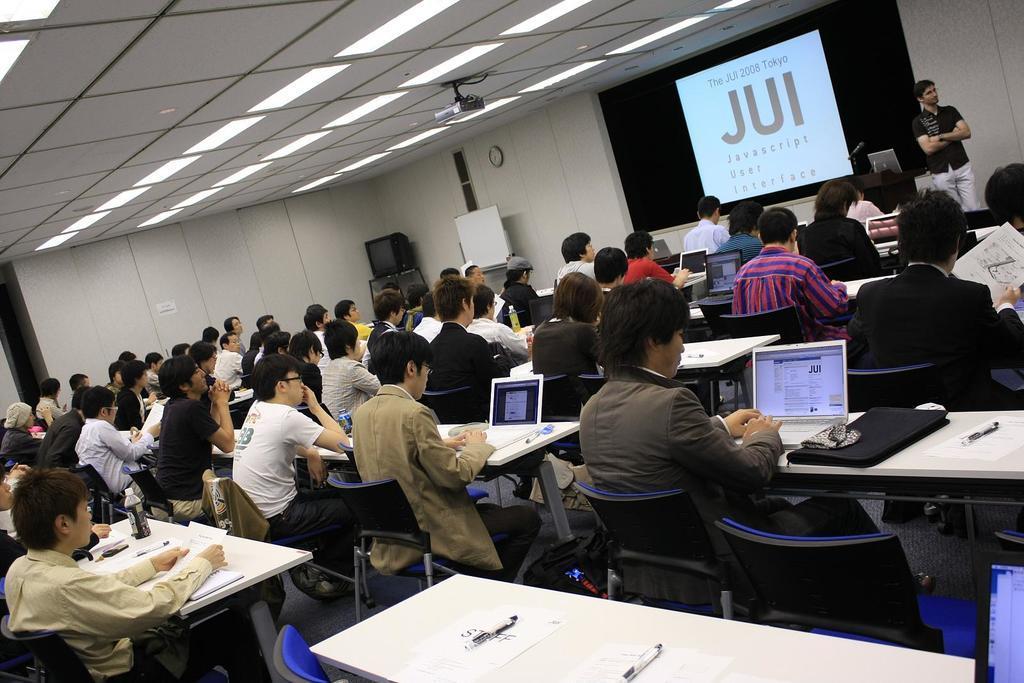In one or two sentences, can you explain what this image depicts? In this picture there are people those who are sitting in the center of the image, there are laptops on benches and there is a projector screen at the top side of the image, there is a man on the right side of the image. 